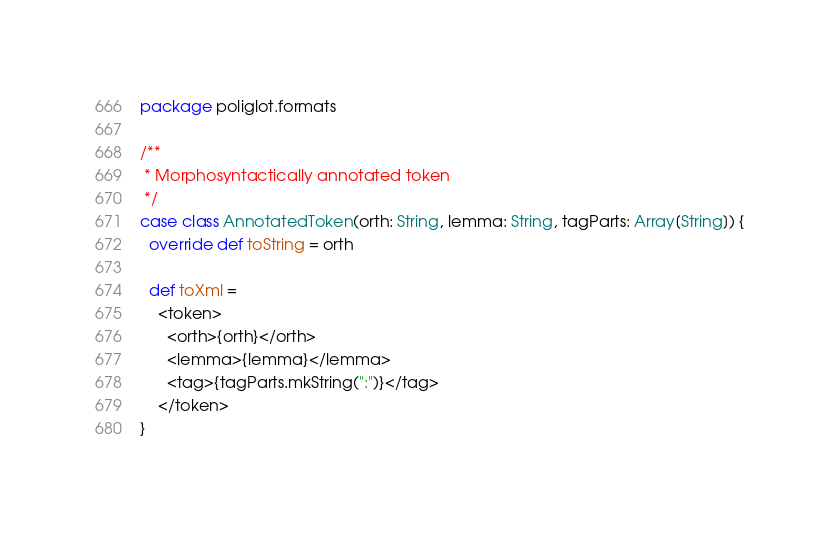<code> <loc_0><loc_0><loc_500><loc_500><_Scala_>package poliglot.formats

/**
 * Morphosyntactically annotated token
 */
case class AnnotatedToken(orth: String, lemma: String, tagParts: Array[String]) {
  override def toString = orth

  def toXml =
    <token>
      <orth>{orth}</orth>
      <lemma>{lemma}</lemma>
      <tag>{tagParts.mkString(":")}</tag>
    </token>
}
</code> 